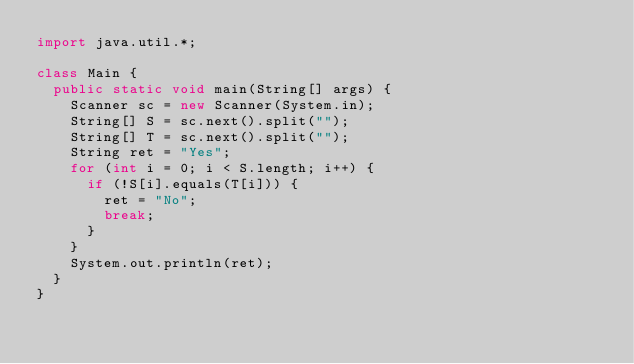Convert code to text. <code><loc_0><loc_0><loc_500><loc_500><_Java_>import java.util.*;

class Main {
  public static void main(String[] args) {
    Scanner sc = new Scanner(System.in);
    String[] S = sc.next().split("");
    String[] T = sc.next().split("");
    String ret = "Yes";
    for (int i = 0; i < S.length; i++) {
      if (!S[i].equals(T[i])) {
        ret = "No";
        break;
      }
    }
    System.out.println(ret);
  }
}
</code> 